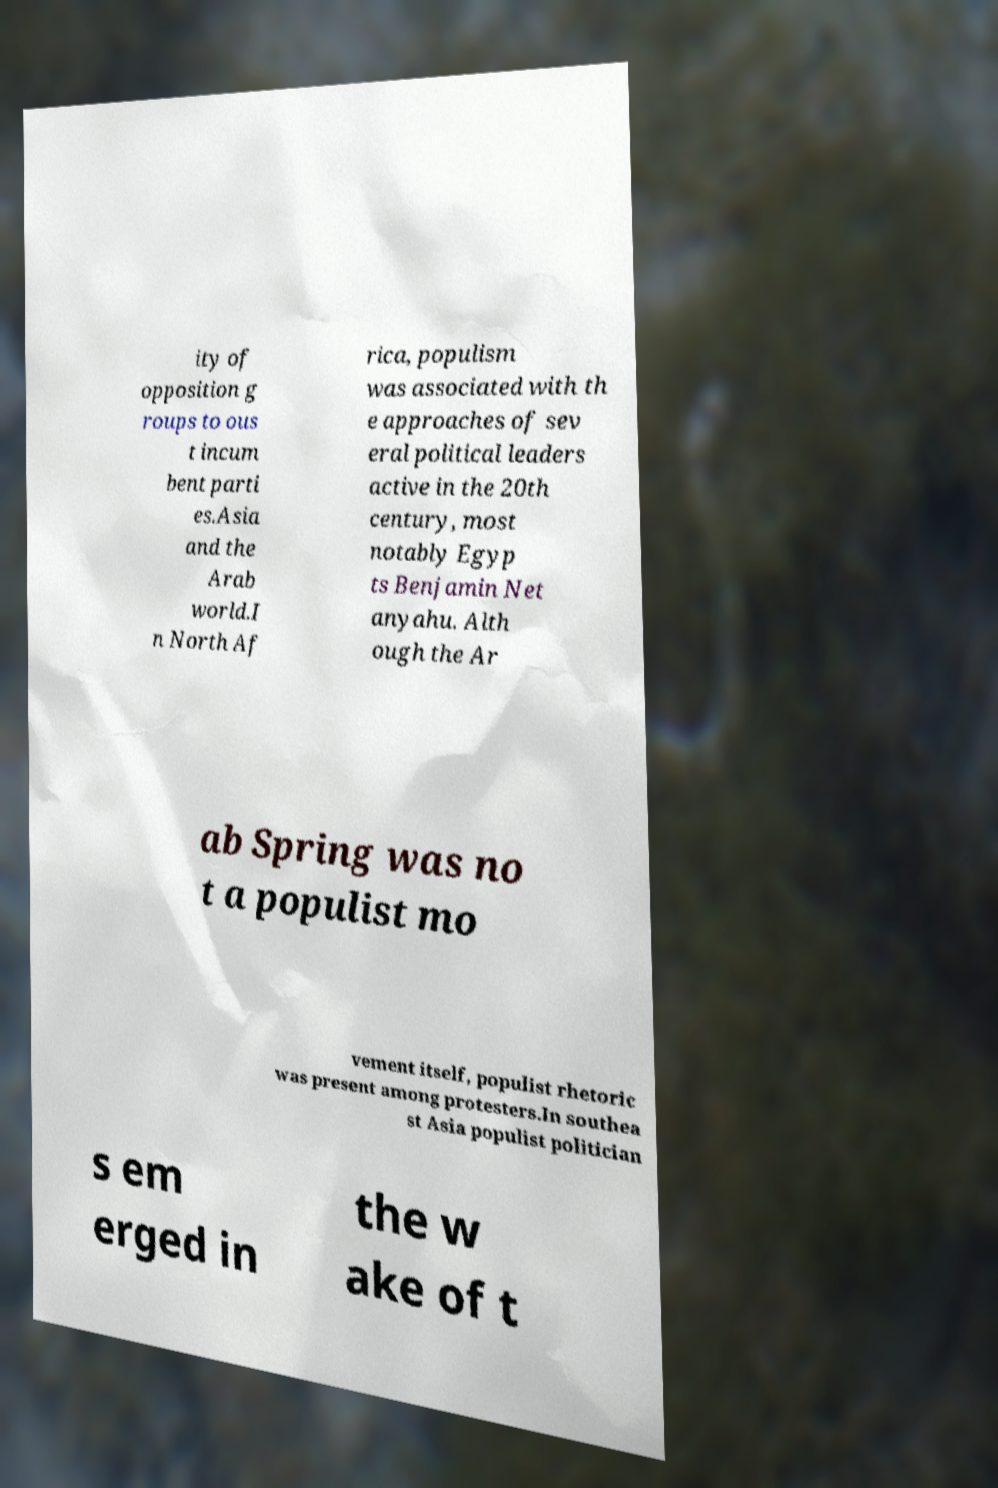Can you read and provide the text displayed in the image?This photo seems to have some interesting text. Can you extract and type it out for me? ity of opposition g roups to ous t incum bent parti es.Asia and the Arab world.I n North Af rica, populism was associated with th e approaches of sev eral political leaders active in the 20th century, most notably Egyp ts Benjamin Net anyahu. Alth ough the Ar ab Spring was no t a populist mo vement itself, populist rhetoric was present among protesters.In southea st Asia populist politician s em erged in the w ake of t 